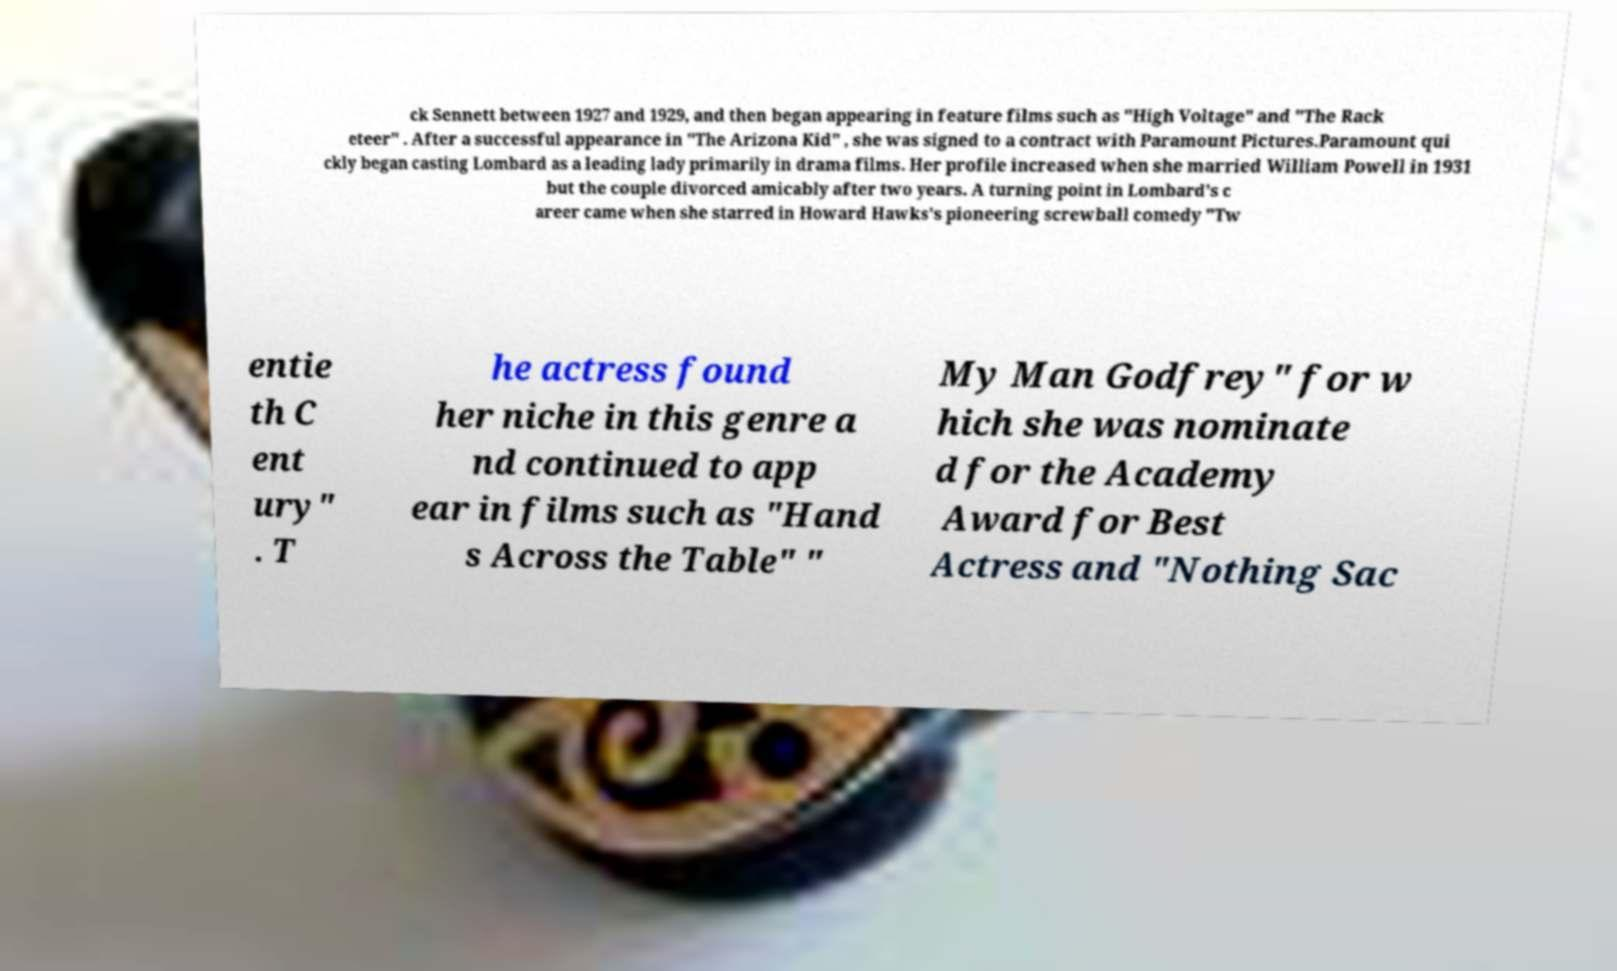There's text embedded in this image that I need extracted. Can you transcribe it verbatim? ck Sennett between 1927 and 1929, and then began appearing in feature films such as "High Voltage" and "The Rack eteer" . After a successful appearance in "The Arizona Kid" , she was signed to a contract with Paramount Pictures.Paramount qui ckly began casting Lombard as a leading lady primarily in drama films. Her profile increased when she married William Powell in 1931 but the couple divorced amicably after two years. A turning point in Lombard's c areer came when she starred in Howard Hawks's pioneering screwball comedy "Tw entie th C ent ury" . T he actress found her niche in this genre a nd continued to app ear in films such as "Hand s Across the Table" " My Man Godfrey" for w hich she was nominate d for the Academy Award for Best Actress and "Nothing Sac 